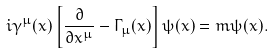<formula> <loc_0><loc_0><loc_500><loc_500>i \gamma ^ { \mu } ( x ) \left [ \frac { \partial } { \partial x ^ { \mu } } - \Gamma _ { \mu } ( x ) \right ] \psi ( x ) = m \psi ( x ) .</formula> 